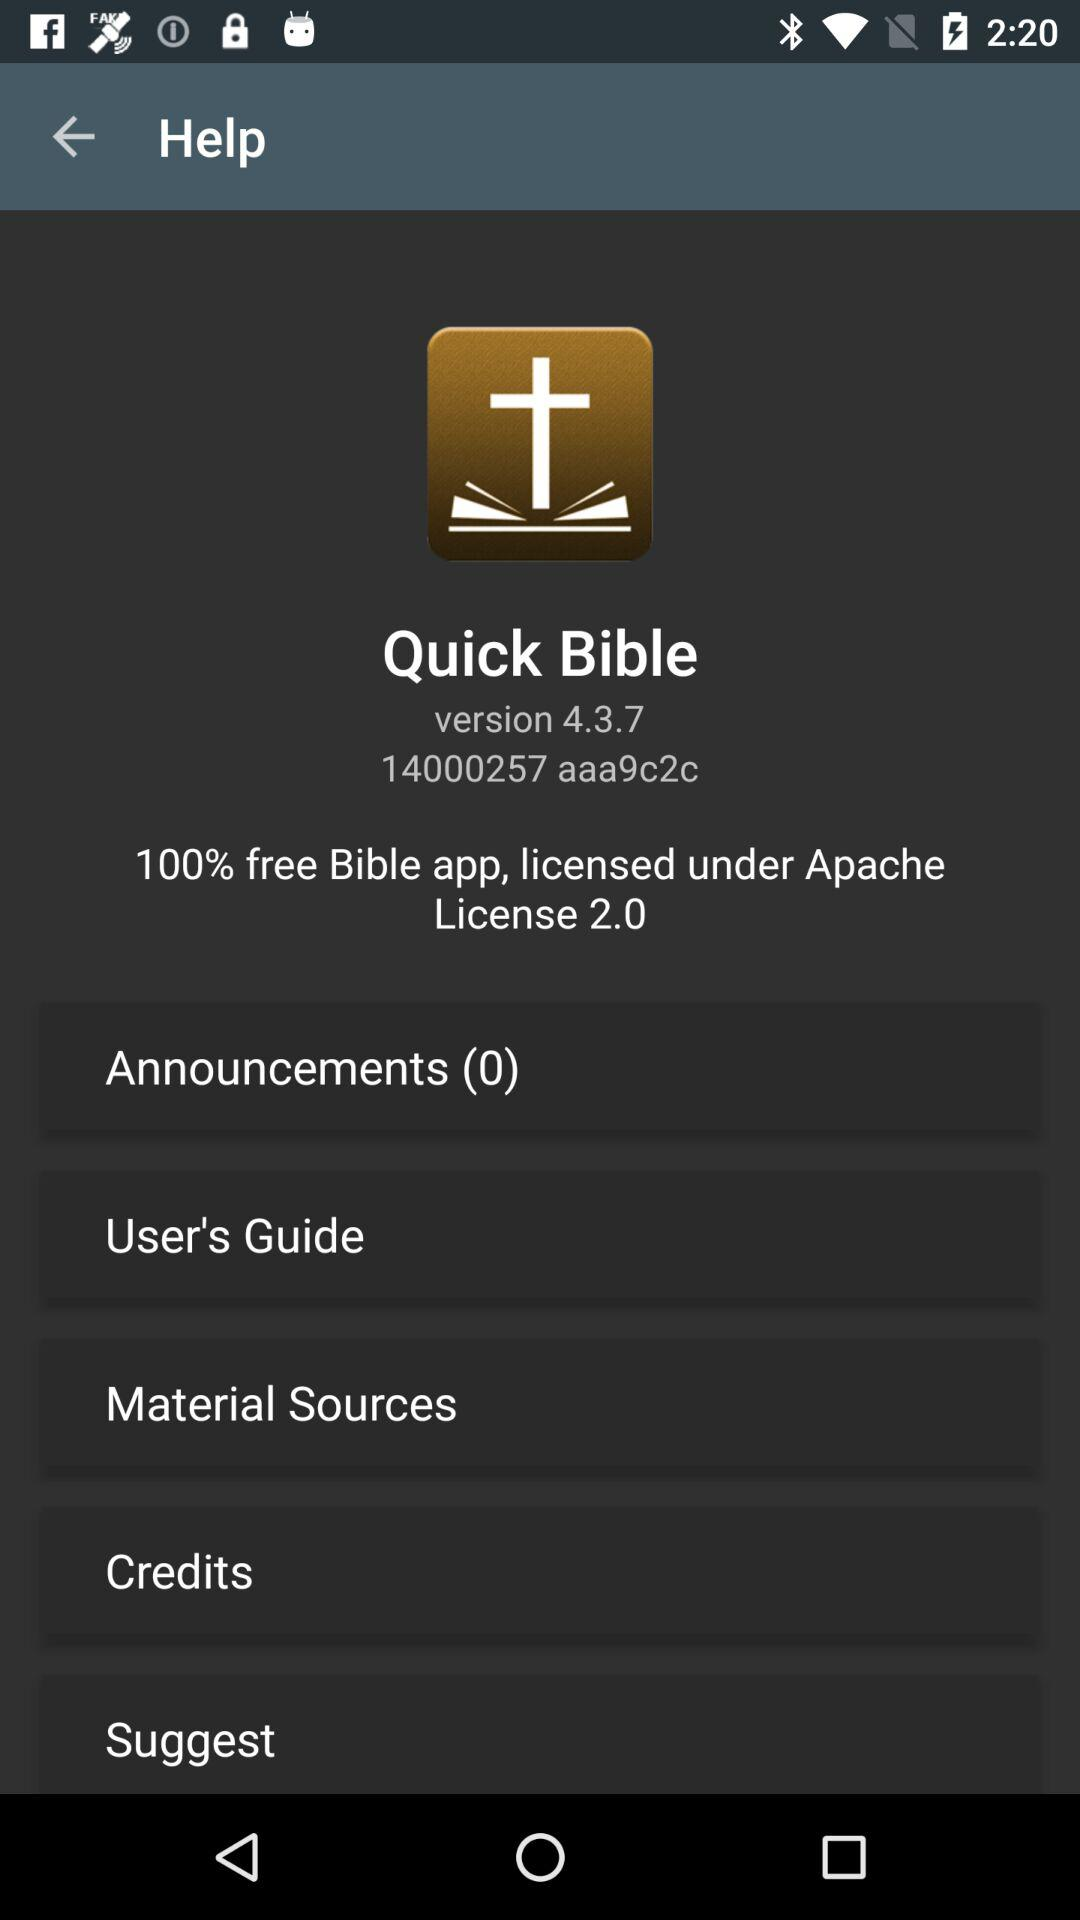Who is the licensor? The licensor is "Apache". 